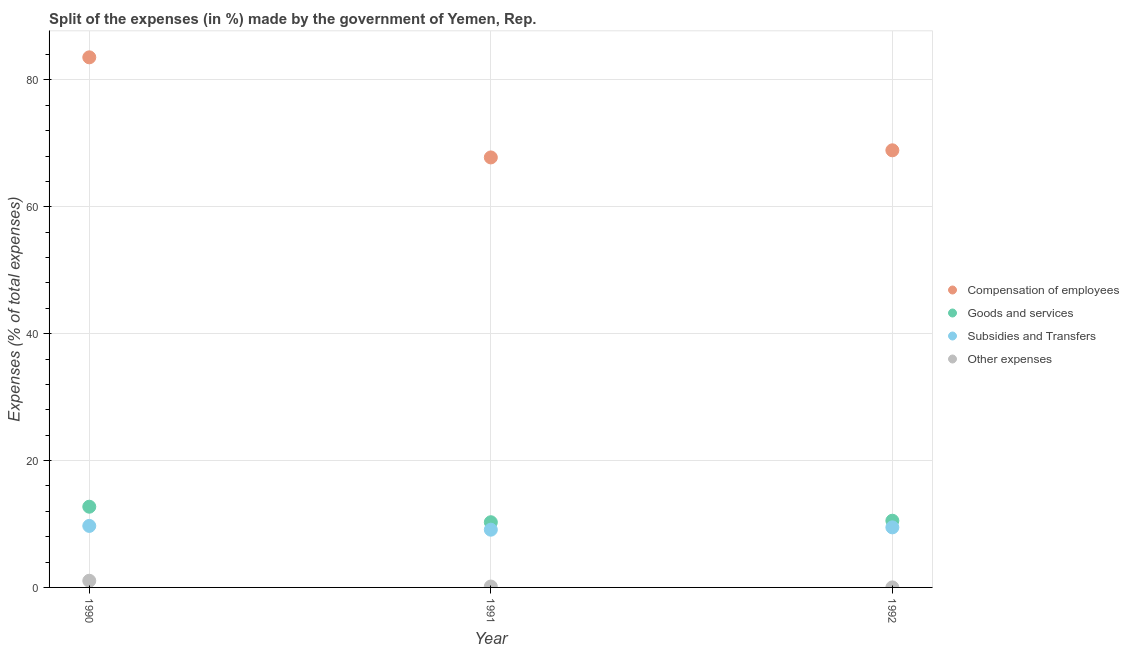How many different coloured dotlines are there?
Give a very brief answer. 4. Is the number of dotlines equal to the number of legend labels?
Give a very brief answer. Yes. What is the percentage of amount spent on subsidies in 1991?
Keep it short and to the point. 9.1. Across all years, what is the maximum percentage of amount spent on goods and services?
Make the answer very short. 12.72. Across all years, what is the minimum percentage of amount spent on other expenses?
Your response must be concise. 0. In which year was the percentage of amount spent on goods and services minimum?
Ensure brevity in your answer.  1991. What is the total percentage of amount spent on subsidies in the graph?
Keep it short and to the point. 28.26. What is the difference between the percentage of amount spent on subsidies in 1990 and that in 1992?
Your response must be concise. 0.23. What is the difference between the percentage of amount spent on other expenses in 1990 and the percentage of amount spent on subsidies in 1991?
Provide a short and direct response. -8.05. What is the average percentage of amount spent on goods and services per year?
Keep it short and to the point. 11.17. In the year 1992, what is the difference between the percentage of amount spent on other expenses and percentage of amount spent on compensation of employees?
Offer a very short reply. -68.9. In how many years, is the percentage of amount spent on subsidies greater than 16 %?
Your response must be concise. 0. What is the ratio of the percentage of amount spent on compensation of employees in 1990 to that in 1992?
Give a very brief answer. 1.21. Is the percentage of amount spent on subsidies in 1990 less than that in 1992?
Provide a succinct answer. No. Is the difference between the percentage of amount spent on other expenses in 1990 and 1992 greater than the difference between the percentage of amount spent on compensation of employees in 1990 and 1992?
Offer a terse response. No. What is the difference between the highest and the second highest percentage of amount spent on compensation of employees?
Make the answer very short. 14.66. What is the difference between the highest and the lowest percentage of amount spent on subsidies?
Your answer should be compact. 0.6. Is it the case that in every year, the sum of the percentage of amount spent on goods and services and percentage of amount spent on subsidies is greater than the sum of percentage of amount spent on compensation of employees and percentage of amount spent on other expenses?
Your answer should be very brief. No. Is it the case that in every year, the sum of the percentage of amount spent on compensation of employees and percentage of amount spent on goods and services is greater than the percentage of amount spent on subsidies?
Offer a terse response. Yes. Does the percentage of amount spent on other expenses monotonically increase over the years?
Keep it short and to the point. No. How many dotlines are there?
Give a very brief answer. 4. Does the graph contain any zero values?
Keep it short and to the point. No. Where does the legend appear in the graph?
Your answer should be very brief. Center right. What is the title of the graph?
Offer a terse response. Split of the expenses (in %) made by the government of Yemen, Rep. Does "Insurance services" appear as one of the legend labels in the graph?
Your answer should be compact. No. What is the label or title of the X-axis?
Provide a short and direct response. Year. What is the label or title of the Y-axis?
Your answer should be very brief. Expenses (% of total expenses). What is the Expenses (% of total expenses) of Compensation of employees in 1990?
Your answer should be very brief. 83.56. What is the Expenses (% of total expenses) in Goods and services in 1990?
Your answer should be compact. 12.72. What is the Expenses (% of total expenses) in Subsidies and Transfers in 1990?
Your response must be concise. 9.7. What is the Expenses (% of total expenses) in Other expenses in 1990?
Your answer should be compact. 1.05. What is the Expenses (% of total expenses) in Compensation of employees in 1991?
Offer a very short reply. 67.78. What is the Expenses (% of total expenses) in Goods and services in 1991?
Keep it short and to the point. 10.28. What is the Expenses (% of total expenses) of Subsidies and Transfers in 1991?
Offer a very short reply. 9.1. What is the Expenses (% of total expenses) of Other expenses in 1991?
Offer a very short reply. 0.14. What is the Expenses (% of total expenses) of Compensation of employees in 1992?
Provide a short and direct response. 68.91. What is the Expenses (% of total expenses) of Goods and services in 1992?
Provide a short and direct response. 10.51. What is the Expenses (% of total expenses) in Subsidies and Transfers in 1992?
Make the answer very short. 9.47. What is the Expenses (% of total expenses) in Other expenses in 1992?
Provide a succinct answer. 0. Across all years, what is the maximum Expenses (% of total expenses) of Compensation of employees?
Keep it short and to the point. 83.56. Across all years, what is the maximum Expenses (% of total expenses) of Goods and services?
Give a very brief answer. 12.72. Across all years, what is the maximum Expenses (% of total expenses) of Subsidies and Transfers?
Provide a short and direct response. 9.7. Across all years, what is the maximum Expenses (% of total expenses) of Other expenses?
Your answer should be compact. 1.05. Across all years, what is the minimum Expenses (% of total expenses) in Compensation of employees?
Offer a terse response. 67.78. Across all years, what is the minimum Expenses (% of total expenses) of Goods and services?
Provide a short and direct response. 10.28. Across all years, what is the minimum Expenses (% of total expenses) of Subsidies and Transfers?
Offer a very short reply. 9.1. Across all years, what is the minimum Expenses (% of total expenses) in Other expenses?
Make the answer very short. 0. What is the total Expenses (% of total expenses) of Compensation of employees in the graph?
Provide a short and direct response. 220.25. What is the total Expenses (% of total expenses) in Goods and services in the graph?
Ensure brevity in your answer.  33.51. What is the total Expenses (% of total expenses) of Subsidies and Transfers in the graph?
Keep it short and to the point. 28.26. What is the total Expenses (% of total expenses) of Other expenses in the graph?
Provide a succinct answer. 1.19. What is the difference between the Expenses (% of total expenses) in Compensation of employees in 1990 and that in 1991?
Give a very brief answer. 15.78. What is the difference between the Expenses (% of total expenses) in Goods and services in 1990 and that in 1991?
Your response must be concise. 2.45. What is the difference between the Expenses (% of total expenses) of Subsidies and Transfers in 1990 and that in 1991?
Give a very brief answer. 0.6. What is the difference between the Expenses (% of total expenses) in Other expenses in 1990 and that in 1991?
Your answer should be very brief. 0.91. What is the difference between the Expenses (% of total expenses) in Compensation of employees in 1990 and that in 1992?
Offer a very short reply. 14.66. What is the difference between the Expenses (% of total expenses) in Goods and services in 1990 and that in 1992?
Your answer should be very brief. 2.21. What is the difference between the Expenses (% of total expenses) in Subsidies and Transfers in 1990 and that in 1992?
Your answer should be compact. 0.23. What is the difference between the Expenses (% of total expenses) of Other expenses in 1990 and that in 1992?
Provide a succinct answer. 1.05. What is the difference between the Expenses (% of total expenses) in Compensation of employees in 1991 and that in 1992?
Provide a succinct answer. -1.12. What is the difference between the Expenses (% of total expenses) of Goods and services in 1991 and that in 1992?
Your answer should be very brief. -0.24. What is the difference between the Expenses (% of total expenses) of Subsidies and Transfers in 1991 and that in 1992?
Offer a terse response. -0.37. What is the difference between the Expenses (% of total expenses) of Other expenses in 1991 and that in 1992?
Ensure brevity in your answer.  0.14. What is the difference between the Expenses (% of total expenses) of Compensation of employees in 1990 and the Expenses (% of total expenses) of Goods and services in 1991?
Your response must be concise. 73.29. What is the difference between the Expenses (% of total expenses) in Compensation of employees in 1990 and the Expenses (% of total expenses) in Subsidies and Transfers in 1991?
Your answer should be compact. 74.46. What is the difference between the Expenses (% of total expenses) of Compensation of employees in 1990 and the Expenses (% of total expenses) of Other expenses in 1991?
Offer a terse response. 83.42. What is the difference between the Expenses (% of total expenses) of Goods and services in 1990 and the Expenses (% of total expenses) of Subsidies and Transfers in 1991?
Your response must be concise. 3.62. What is the difference between the Expenses (% of total expenses) of Goods and services in 1990 and the Expenses (% of total expenses) of Other expenses in 1991?
Offer a terse response. 12.58. What is the difference between the Expenses (% of total expenses) in Subsidies and Transfers in 1990 and the Expenses (% of total expenses) in Other expenses in 1991?
Ensure brevity in your answer.  9.56. What is the difference between the Expenses (% of total expenses) of Compensation of employees in 1990 and the Expenses (% of total expenses) of Goods and services in 1992?
Your answer should be compact. 73.05. What is the difference between the Expenses (% of total expenses) of Compensation of employees in 1990 and the Expenses (% of total expenses) of Subsidies and Transfers in 1992?
Make the answer very short. 74.09. What is the difference between the Expenses (% of total expenses) in Compensation of employees in 1990 and the Expenses (% of total expenses) in Other expenses in 1992?
Provide a short and direct response. 83.56. What is the difference between the Expenses (% of total expenses) of Goods and services in 1990 and the Expenses (% of total expenses) of Subsidies and Transfers in 1992?
Ensure brevity in your answer.  3.26. What is the difference between the Expenses (% of total expenses) of Goods and services in 1990 and the Expenses (% of total expenses) of Other expenses in 1992?
Provide a succinct answer. 12.72. What is the difference between the Expenses (% of total expenses) of Subsidies and Transfers in 1990 and the Expenses (% of total expenses) of Other expenses in 1992?
Make the answer very short. 9.69. What is the difference between the Expenses (% of total expenses) in Compensation of employees in 1991 and the Expenses (% of total expenses) in Goods and services in 1992?
Offer a very short reply. 57.27. What is the difference between the Expenses (% of total expenses) in Compensation of employees in 1991 and the Expenses (% of total expenses) in Subsidies and Transfers in 1992?
Make the answer very short. 58.32. What is the difference between the Expenses (% of total expenses) in Compensation of employees in 1991 and the Expenses (% of total expenses) in Other expenses in 1992?
Keep it short and to the point. 67.78. What is the difference between the Expenses (% of total expenses) of Goods and services in 1991 and the Expenses (% of total expenses) of Subsidies and Transfers in 1992?
Ensure brevity in your answer.  0.81. What is the difference between the Expenses (% of total expenses) in Goods and services in 1991 and the Expenses (% of total expenses) in Other expenses in 1992?
Your response must be concise. 10.27. What is the difference between the Expenses (% of total expenses) of Subsidies and Transfers in 1991 and the Expenses (% of total expenses) of Other expenses in 1992?
Your response must be concise. 9.1. What is the average Expenses (% of total expenses) of Compensation of employees per year?
Provide a succinct answer. 73.42. What is the average Expenses (% of total expenses) of Goods and services per year?
Provide a succinct answer. 11.17. What is the average Expenses (% of total expenses) in Subsidies and Transfers per year?
Offer a very short reply. 9.42. What is the average Expenses (% of total expenses) of Other expenses per year?
Ensure brevity in your answer.  0.4. In the year 1990, what is the difference between the Expenses (% of total expenses) in Compensation of employees and Expenses (% of total expenses) in Goods and services?
Provide a short and direct response. 70.84. In the year 1990, what is the difference between the Expenses (% of total expenses) in Compensation of employees and Expenses (% of total expenses) in Subsidies and Transfers?
Offer a very short reply. 73.87. In the year 1990, what is the difference between the Expenses (% of total expenses) in Compensation of employees and Expenses (% of total expenses) in Other expenses?
Ensure brevity in your answer.  82.51. In the year 1990, what is the difference between the Expenses (% of total expenses) of Goods and services and Expenses (% of total expenses) of Subsidies and Transfers?
Your response must be concise. 3.03. In the year 1990, what is the difference between the Expenses (% of total expenses) of Goods and services and Expenses (% of total expenses) of Other expenses?
Your answer should be compact. 11.67. In the year 1990, what is the difference between the Expenses (% of total expenses) of Subsidies and Transfers and Expenses (% of total expenses) of Other expenses?
Offer a very short reply. 8.65. In the year 1991, what is the difference between the Expenses (% of total expenses) of Compensation of employees and Expenses (% of total expenses) of Goods and services?
Your answer should be compact. 57.51. In the year 1991, what is the difference between the Expenses (% of total expenses) in Compensation of employees and Expenses (% of total expenses) in Subsidies and Transfers?
Provide a short and direct response. 58.68. In the year 1991, what is the difference between the Expenses (% of total expenses) of Compensation of employees and Expenses (% of total expenses) of Other expenses?
Offer a terse response. 67.64. In the year 1991, what is the difference between the Expenses (% of total expenses) of Goods and services and Expenses (% of total expenses) of Subsidies and Transfers?
Give a very brief answer. 1.18. In the year 1991, what is the difference between the Expenses (% of total expenses) of Goods and services and Expenses (% of total expenses) of Other expenses?
Your answer should be compact. 10.14. In the year 1991, what is the difference between the Expenses (% of total expenses) of Subsidies and Transfers and Expenses (% of total expenses) of Other expenses?
Give a very brief answer. 8.96. In the year 1992, what is the difference between the Expenses (% of total expenses) in Compensation of employees and Expenses (% of total expenses) in Goods and services?
Your answer should be very brief. 58.39. In the year 1992, what is the difference between the Expenses (% of total expenses) in Compensation of employees and Expenses (% of total expenses) in Subsidies and Transfers?
Offer a terse response. 59.44. In the year 1992, what is the difference between the Expenses (% of total expenses) of Compensation of employees and Expenses (% of total expenses) of Other expenses?
Provide a short and direct response. 68.9. In the year 1992, what is the difference between the Expenses (% of total expenses) of Goods and services and Expenses (% of total expenses) of Subsidies and Transfers?
Provide a short and direct response. 1.05. In the year 1992, what is the difference between the Expenses (% of total expenses) in Goods and services and Expenses (% of total expenses) in Other expenses?
Your response must be concise. 10.51. In the year 1992, what is the difference between the Expenses (% of total expenses) in Subsidies and Transfers and Expenses (% of total expenses) in Other expenses?
Provide a short and direct response. 9.47. What is the ratio of the Expenses (% of total expenses) of Compensation of employees in 1990 to that in 1991?
Offer a terse response. 1.23. What is the ratio of the Expenses (% of total expenses) in Goods and services in 1990 to that in 1991?
Your answer should be compact. 1.24. What is the ratio of the Expenses (% of total expenses) of Subsidies and Transfers in 1990 to that in 1991?
Make the answer very short. 1.07. What is the ratio of the Expenses (% of total expenses) of Other expenses in 1990 to that in 1991?
Make the answer very short. 7.5. What is the ratio of the Expenses (% of total expenses) of Compensation of employees in 1990 to that in 1992?
Your answer should be compact. 1.21. What is the ratio of the Expenses (% of total expenses) of Goods and services in 1990 to that in 1992?
Offer a terse response. 1.21. What is the ratio of the Expenses (% of total expenses) of Subsidies and Transfers in 1990 to that in 1992?
Provide a short and direct response. 1.02. What is the ratio of the Expenses (% of total expenses) in Other expenses in 1990 to that in 1992?
Keep it short and to the point. 617.49. What is the ratio of the Expenses (% of total expenses) of Compensation of employees in 1991 to that in 1992?
Make the answer very short. 0.98. What is the ratio of the Expenses (% of total expenses) of Goods and services in 1991 to that in 1992?
Your answer should be compact. 0.98. What is the ratio of the Expenses (% of total expenses) of Subsidies and Transfers in 1991 to that in 1992?
Provide a short and direct response. 0.96. What is the ratio of the Expenses (% of total expenses) of Other expenses in 1991 to that in 1992?
Keep it short and to the point. 82.32. What is the difference between the highest and the second highest Expenses (% of total expenses) in Compensation of employees?
Ensure brevity in your answer.  14.66. What is the difference between the highest and the second highest Expenses (% of total expenses) of Goods and services?
Provide a succinct answer. 2.21. What is the difference between the highest and the second highest Expenses (% of total expenses) in Subsidies and Transfers?
Your answer should be compact. 0.23. What is the difference between the highest and the second highest Expenses (% of total expenses) in Other expenses?
Give a very brief answer. 0.91. What is the difference between the highest and the lowest Expenses (% of total expenses) in Compensation of employees?
Make the answer very short. 15.78. What is the difference between the highest and the lowest Expenses (% of total expenses) of Goods and services?
Your answer should be very brief. 2.45. What is the difference between the highest and the lowest Expenses (% of total expenses) of Subsidies and Transfers?
Your answer should be very brief. 0.6. What is the difference between the highest and the lowest Expenses (% of total expenses) in Other expenses?
Make the answer very short. 1.05. 